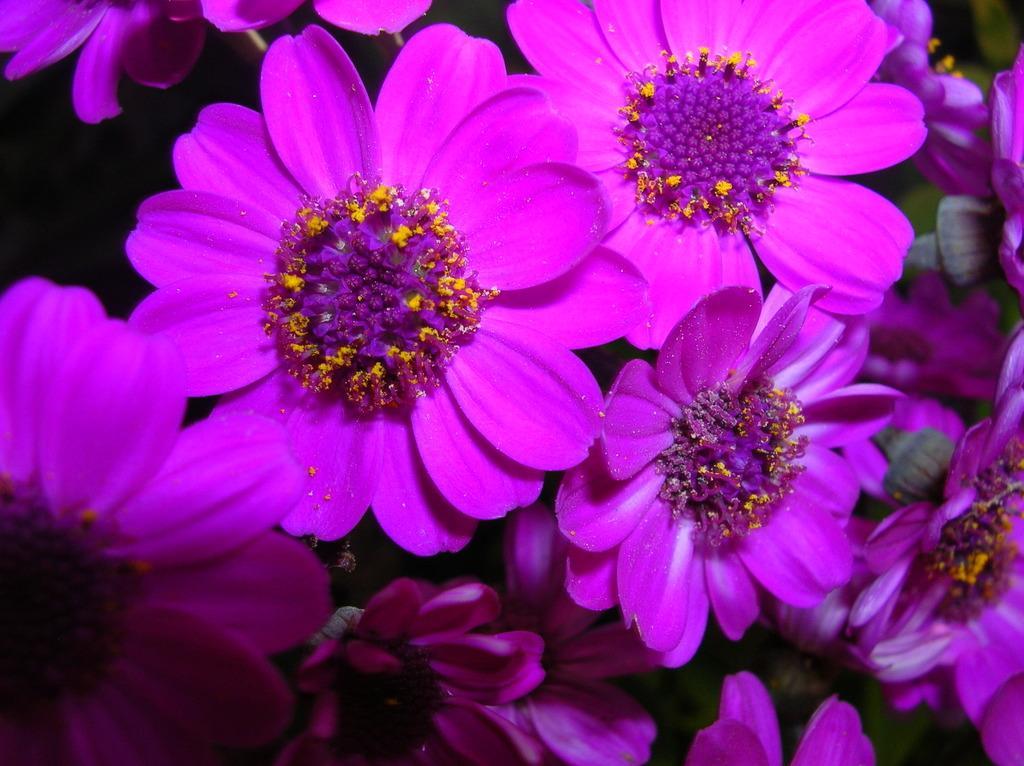In one or two sentences, can you explain what this image depicts? In this image there are flowers. 